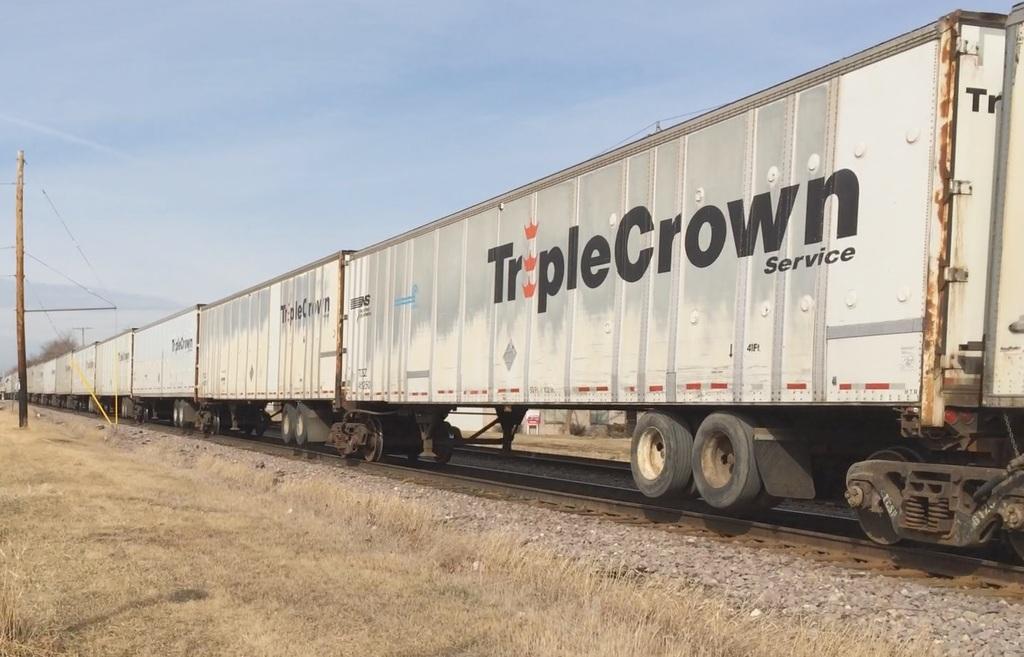Which company operate this freight?
Your response must be concise. Triple crown. What is the smaller word on the trailer?
Give a very brief answer. Service. 